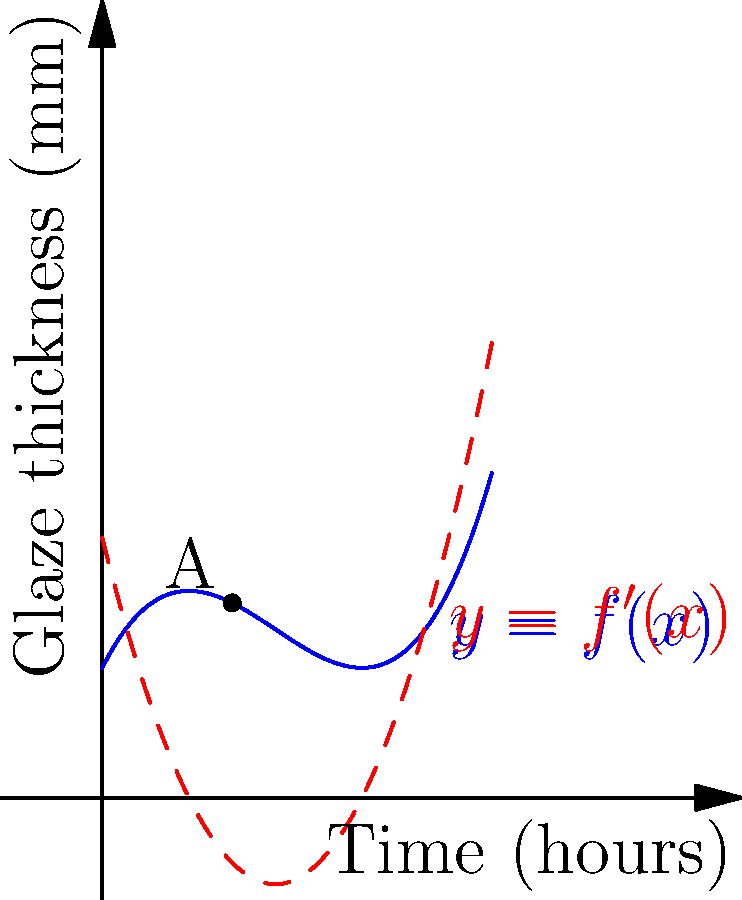As a ceramic artist working with exclusive materials, you're monitoring the glaze thickness during firing. The blue curve represents the glaze thickness $y = f(x)$ in millimeters as a function of time $x$ in hours. The red dashed curve represents the rate of change of glaze thickness, $f'(x)$. At point A, after 1 hour of firing, what is the instantaneous rate of change of glaze thickness? To find the instantaneous rate of change of glaze thickness at point A (after 1 hour of firing), we need to follow these steps:

1) The red dashed curve represents $f'(x)$, which is the derivative of $f(x)$.

2) We're given that $f(x) = 0.5x^3 - 2x^2 + 2x + 1$.

3) To find $f'(x)$, we differentiate $f(x)$:
   $f'(x) = 1.5x^2 - 4x + 2$

4) Point A is at $x = 1$ hour. To find the instantaneous rate of change at this point, we need to evaluate $f'(1)$:

   $f'(1) = 1.5(1)^2 - 4(1) + 2$
   $= 1.5 - 4 + 2$
   $= -0.5$

5) The negative value indicates that the glaze thickness is decreasing at this point.

Therefore, after 1 hour of firing, the instantaneous rate of change of glaze thickness is -0.5 mm/hour.
Answer: $-0.5$ mm/hour 